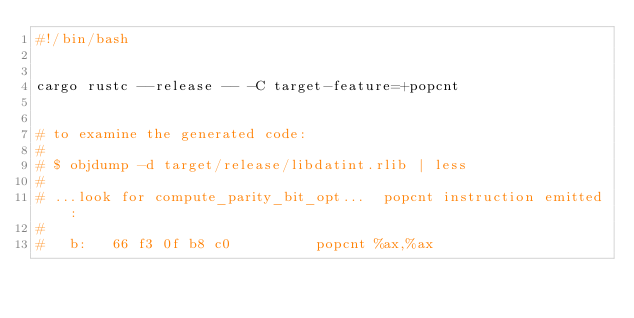Convert code to text. <code><loc_0><loc_0><loc_500><loc_500><_Bash_>#!/bin/bash


cargo rustc --release -- -C target-feature=+popcnt


# to examine the generated code:
#
# $ objdump -d target/release/libdatint.rlib | less
#
# ...look for compute_parity_bit_opt...  popcnt instruction emitted:
#
#   b:   66 f3 0f b8 c0          popcnt %ax,%ax
</code> 